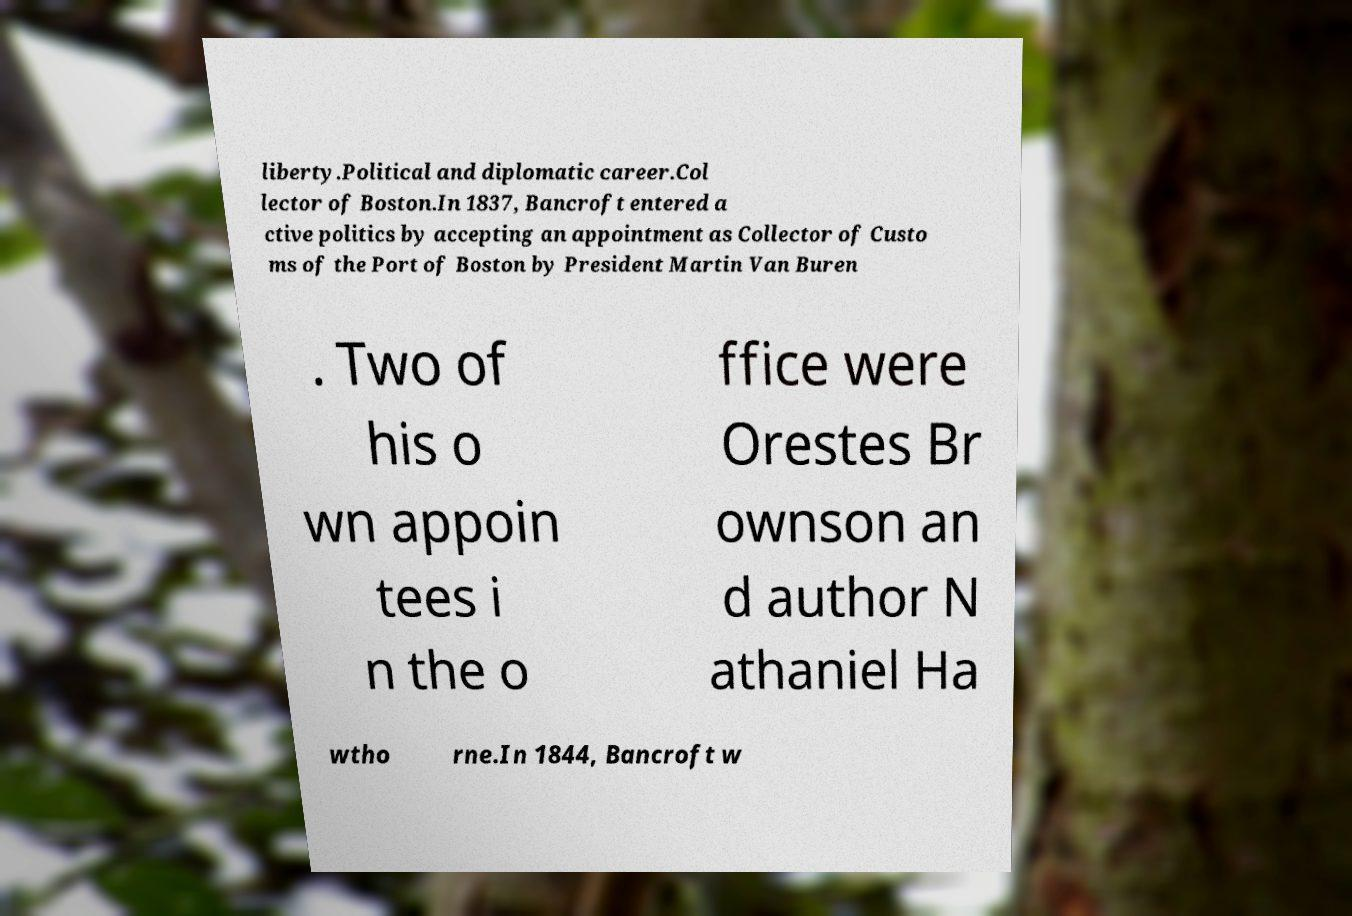Please read and relay the text visible in this image. What does it say? liberty.Political and diplomatic career.Col lector of Boston.In 1837, Bancroft entered a ctive politics by accepting an appointment as Collector of Custo ms of the Port of Boston by President Martin Van Buren . Two of his o wn appoin tees i n the o ffice were Orestes Br ownson an d author N athaniel Ha wtho rne.In 1844, Bancroft w 